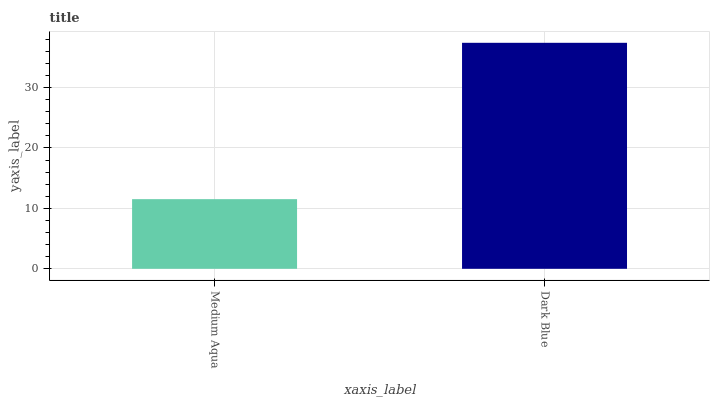Is Medium Aqua the minimum?
Answer yes or no. Yes. Is Dark Blue the maximum?
Answer yes or no. Yes. Is Dark Blue the minimum?
Answer yes or no. No. Is Dark Blue greater than Medium Aqua?
Answer yes or no. Yes. Is Medium Aqua less than Dark Blue?
Answer yes or no. Yes. Is Medium Aqua greater than Dark Blue?
Answer yes or no. No. Is Dark Blue less than Medium Aqua?
Answer yes or no. No. Is Dark Blue the high median?
Answer yes or no. Yes. Is Medium Aqua the low median?
Answer yes or no. Yes. Is Medium Aqua the high median?
Answer yes or no. No. Is Dark Blue the low median?
Answer yes or no. No. 